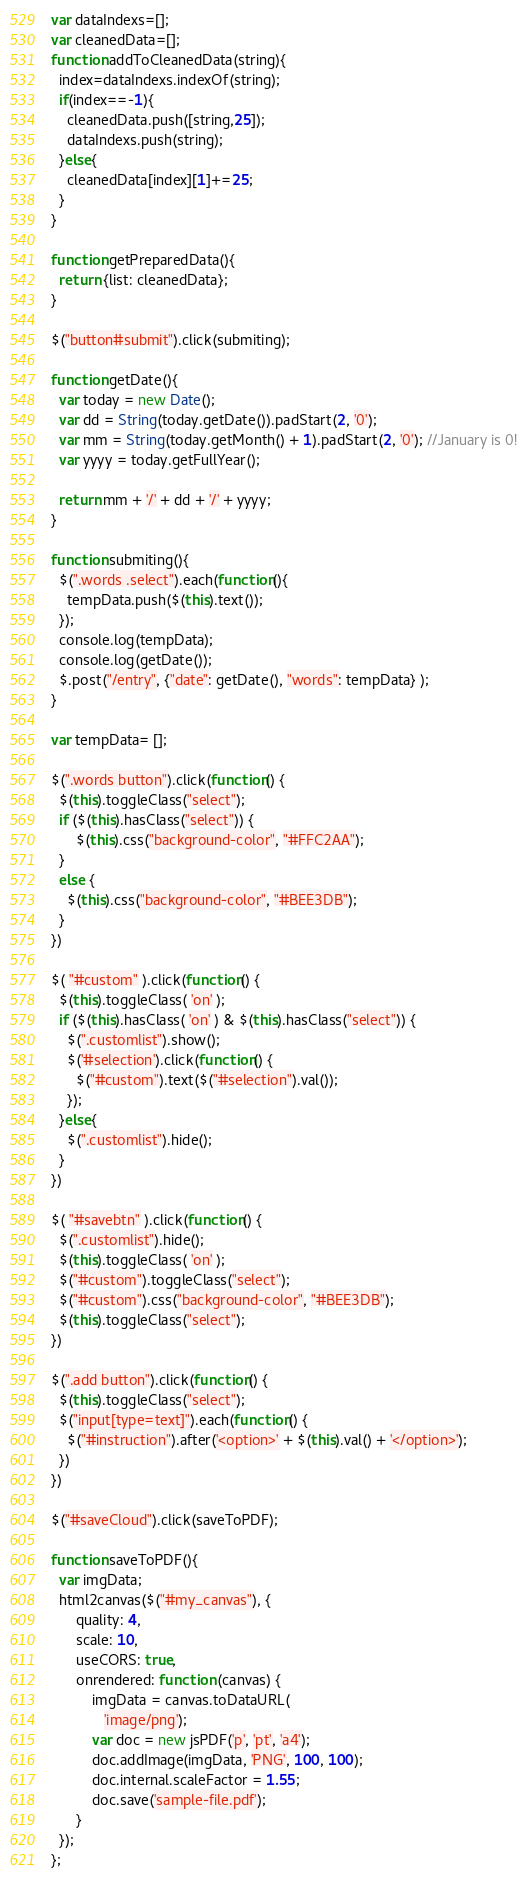<code> <loc_0><loc_0><loc_500><loc_500><_JavaScript_>var dataIndexs=[];
var cleanedData=[];
function addToCleanedData(string){
  index=dataIndexs.indexOf(string);
  if(index==-1){
    cleanedData.push([string,25]);
    dataIndexs.push(string);
  }else{
    cleanedData[index][1]+=25;
  }
}

function getPreparedData(){
  return {list: cleanedData};
}

$("button#submit").click(submiting);

function getDate(){
  var today = new Date();
  var dd = String(today.getDate()).padStart(2, '0');
  var mm = String(today.getMonth() + 1).padStart(2, '0'); //January is 0!
  var yyyy = today.getFullYear();

  return mm + '/' + dd + '/' + yyyy;
}

function submiting(){
  $(".words .select").each(function(){
    tempData.push($(this).text());
  });
  console.log(tempData);
  console.log(getDate());
  $.post("/entry", {"date": getDate(), "words": tempData} );
}

var tempData= [];

$(".words button").click(function() {
  $(this).toggleClass("select");
  if ($(this).hasClass("select")) {
      $(this).css("background-color", "#FFC2AA");
  }
  else {
    $(this).css("background-color", "#BEE3DB");
  }
})

$( "#custom" ).click(function() {
  $(this).toggleClass( 'on' );
  if ($(this).hasClass( 'on' ) & $(this).hasClass("select")) {
    $(".customlist").show();
    $('#selection').click(function() {
      $("#custom").text($("#selection").val());
    });
  }else{
    $(".customlist").hide();
  }
})

$( "#savebtn" ).click(function() {
  $(".customlist").hide();
  $(this).toggleClass( 'on' );
  $("#custom").toggleClass("select");
  $("#custom").css("background-color", "#BEE3DB");
  $(this).toggleClass("select");
})

$(".add button").click(function() {
  $(this).toggleClass("select");
  $("input[type=text]").each(function() {
    $("#instruction").after('<option>' + $(this).val() + '</option>');
  })
})

$("#saveCloud").click(saveToPDF);

function saveToPDF(){
  var imgData;
  html2canvas($("#my_canvas"), {
      quality: 4,
      scale: 10,
      useCORS: true,
      onrendered: function (canvas) {
          imgData = canvas.toDataURL(
             'image/png');
          var doc = new jsPDF('p', 'pt', 'a4');
          doc.addImage(imgData, 'PNG', 100, 100);
          doc.internal.scaleFactor = 1.55;
          doc.save('sample-file.pdf');
      }
  });
};
</code> 